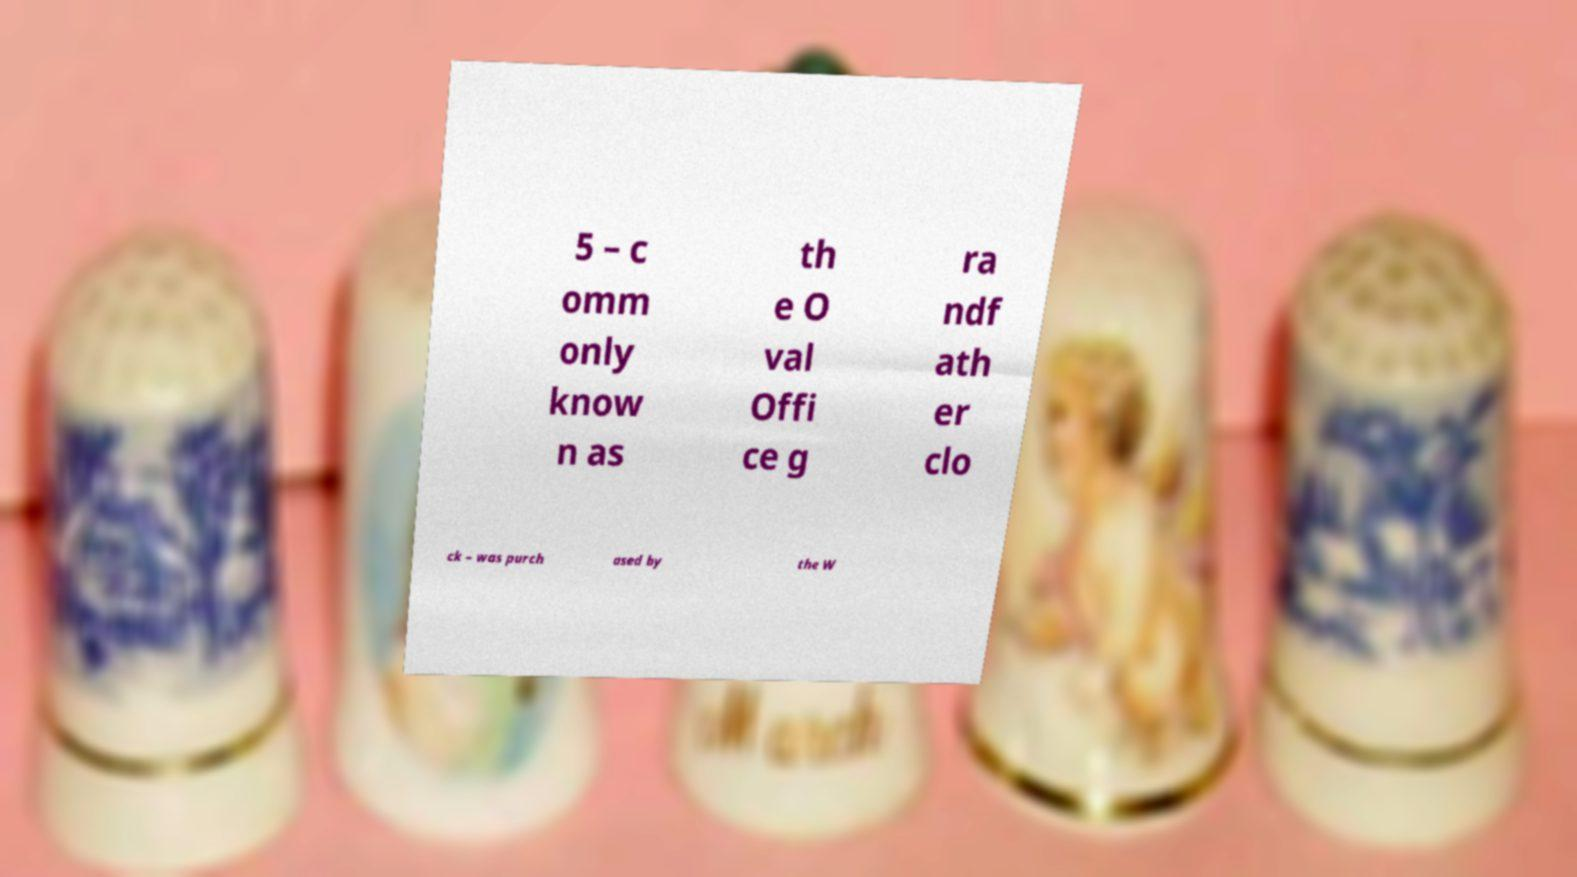Please identify and transcribe the text found in this image. 5 – c omm only know n as th e O val Offi ce g ra ndf ath er clo ck – was purch ased by the W 